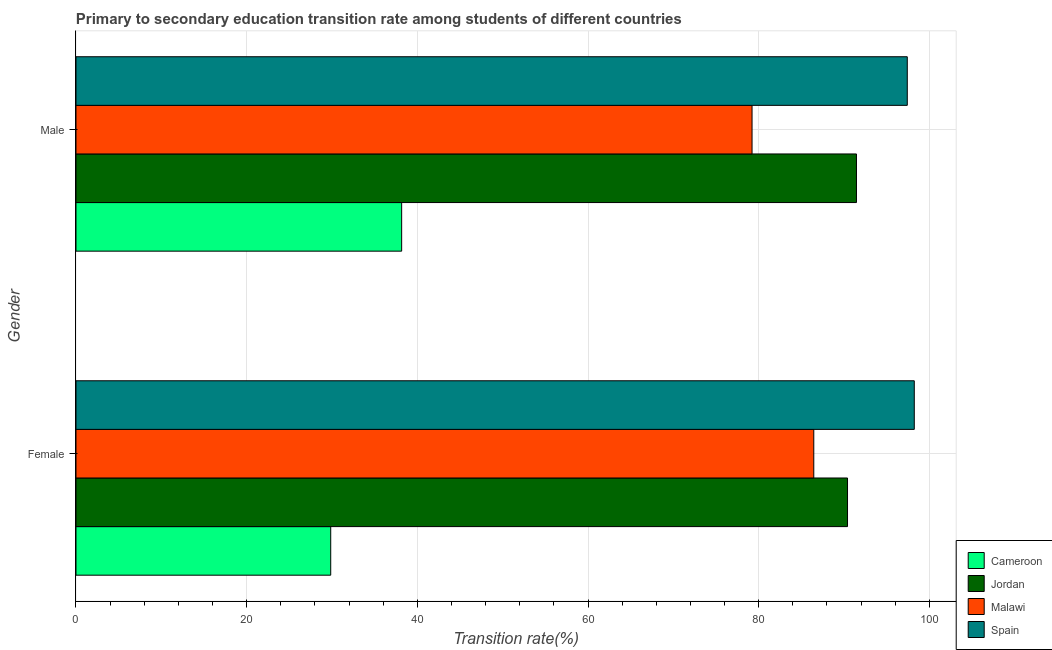How many different coloured bars are there?
Offer a very short reply. 4. How many groups of bars are there?
Offer a terse response. 2. Are the number of bars per tick equal to the number of legend labels?
Your answer should be very brief. Yes. How many bars are there on the 2nd tick from the top?
Ensure brevity in your answer.  4. What is the label of the 2nd group of bars from the top?
Your answer should be very brief. Female. What is the transition rate among male students in Malawi?
Ensure brevity in your answer.  79.22. Across all countries, what is the maximum transition rate among male students?
Offer a very short reply. 97.41. Across all countries, what is the minimum transition rate among male students?
Keep it short and to the point. 38.16. In which country was the transition rate among male students minimum?
Ensure brevity in your answer.  Cameroon. What is the total transition rate among male students in the graph?
Your answer should be compact. 306.26. What is the difference between the transition rate among male students in Malawi and that in Cameroon?
Provide a short and direct response. 41.06. What is the difference between the transition rate among female students in Cameroon and the transition rate among male students in Malawi?
Make the answer very short. -49.37. What is the average transition rate among male students per country?
Your answer should be compact. 76.57. What is the difference between the transition rate among female students and transition rate among male students in Spain?
Provide a succinct answer. 0.82. In how many countries, is the transition rate among female students greater than 24 %?
Give a very brief answer. 4. What is the ratio of the transition rate among male students in Malawi to that in Jordan?
Make the answer very short. 0.87. Is the transition rate among female students in Spain less than that in Cameroon?
Provide a short and direct response. No. What does the 4th bar from the top in Male represents?
Provide a succinct answer. Cameroon. What does the 4th bar from the bottom in Male represents?
Provide a short and direct response. Spain. How many bars are there?
Offer a very short reply. 8. Are all the bars in the graph horizontal?
Your answer should be compact. Yes. What is the difference between two consecutive major ticks on the X-axis?
Give a very brief answer. 20. Does the graph contain any zero values?
Keep it short and to the point. No. Does the graph contain grids?
Provide a succinct answer. Yes. Where does the legend appear in the graph?
Provide a short and direct response. Bottom right. How many legend labels are there?
Make the answer very short. 4. How are the legend labels stacked?
Make the answer very short. Vertical. What is the title of the graph?
Ensure brevity in your answer.  Primary to secondary education transition rate among students of different countries. Does "Europe(all income levels)" appear as one of the legend labels in the graph?
Keep it short and to the point. No. What is the label or title of the X-axis?
Offer a terse response. Transition rate(%). What is the Transition rate(%) in Cameroon in Female?
Offer a terse response. 29.85. What is the Transition rate(%) of Jordan in Female?
Give a very brief answer. 90.41. What is the Transition rate(%) in Malawi in Female?
Offer a very short reply. 86.46. What is the Transition rate(%) of Spain in Female?
Your response must be concise. 98.23. What is the Transition rate(%) in Cameroon in Male?
Provide a succinct answer. 38.16. What is the Transition rate(%) of Jordan in Male?
Keep it short and to the point. 91.46. What is the Transition rate(%) of Malawi in Male?
Ensure brevity in your answer.  79.22. What is the Transition rate(%) of Spain in Male?
Offer a terse response. 97.41. Across all Gender, what is the maximum Transition rate(%) in Cameroon?
Offer a terse response. 38.16. Across all Gender, what is the maximum Transition rate(%) of Jordan?
Make the answer very short. 91.46. Across all Gender, what is the maximum Transition rate(%) of Malawi?
Provide a short and direct response. 86.46. Across all Gender, what is the maximum Transition rate(%) in Spain?
Your response must be concise. 98.23. Across all Gender, what is the minimum Transition rate(%) of Cameroon?
Offer a very short reply. 29.85. Across all Gender, what is the minimum Transition rate(%) in Jordan?
Ensure brevity in your answer.  90.41. Across all Gender, what is the minimum Transition rate(%) in Malawi?
Provide a succinct answer. 79.22. Across all Gender, what is the minimum Transition rate(%) in Spain?
Offer a very short reply. 97.41. What is the total Transition rate(%) of Cameroon in the graph?
Offer a terse response. 68.01. What is the total Transition rate(%) in Jordan in the graph?
Your answer should be very brief. 181.87. What is the total Transition rate(%) of Malawi in the graph?
Ensure brevity in your answer.  165.68. What is the total Transition rate(%) of Spain in the graph?
Make the answer very short. 195.65. What is the difference between the Transition rate(%) in Cameroon in Female and that in Male?
Offer a very short reply. -8.31. What is the difference between the Transition rate(%) of Jordan in Female and that in Male?
Keep it short and to the point. -1.05. What is the difference between the Transition rate(%) in Malawi in Female and that in Male?
Give a very brief answer. 7.23. What is the difference between the Transition rate(%) in Spain in Female and that in Male?
Provide a succinct answer. 0.82. What is the difference between the Transition rate(%) of Cameroon in Female and the Transition rate(%) of Jordan in Male?
Your response must be concise. -61.61. What is the difference between the Transition rate(%) of Cameroon in Female and the Transition rate(%) of Malawi in Male?
Ensure brevity in your answer.  -49.37. What is the difference between the Transition rate(%) in Cameroon in Female and the Transition rate(%) in Spain in Male?
Ensure brevity in your answer.  -67.56. What is the difference between the Transition rate(%) in Jordan in Female and the Transition rate(%) in Malawi in Male?
Provide a succinct answer. 11.19. What is the difference between the Transition rate(%) in Jordan in Female and the Transition rate(%) in Spain in Male?
Make the answer very short. -7. What is the difference between the Transition rate(%) of Malawi in Female and the Transition rate(%) of Spain in Male?
Give a very brief answer. -10.96. What is the average Transition rate(%) of Cameroon per Gender?
Your answer should be compact. 34.01. What is the average Transition rate(%) of Jordan per Gender?
Keep it short and to the point. 90.94. What is the average Transition rate(%) of Malawi per Gender?
Provide a succinct answer. 82.84. What is the average Transition rate(%) of Spain per Gender?
Make the answer very short. 97.82. What is the difference between the Transition rate(%) of Cameroon and Transition rate(%) of Jordan in Female?
Make the answer very short. -60.56. What is the difference between the Transition rate(%) of Cameroon and Transition rate(%) of Malawi in Female?
Your answer should be very brief. -56.61. What is the difference between the Transition rate(%) of Cameroon and Transition rate(%) of Spain in Female?
Your answer should be compact. -68.38. What is the difference between the Transition rate(%) in Jordan and Transition rate(%) in Malawi in Female?
Make the answer very short. 3.95. What is the difference between the Transition rate(%) of Jordan and Transition rate(%) of Spain in Female?
Offer a terse response. -7.82. What is the difference between the Transition rate(%) of Malawi and Transition rate(%) of Spain in Female?
Keep it short and to the point. -11.78. What is the difference between the Transition rate(%) of Cameroon and Transition rate(%) of Jordan in Male?
Provide a short and direct response. -53.3. What is the difference between the Transition rate(%) of Cameroon and Transition rate(%) of Malawi in Male?
Ensure brevity in your answer.  -41.06. What is the difference between the Transition rate(%) in Cameroon and Transition rate(%) in Spain in Male?
Offer a very short reply. -59.25. What is the difference between the Transition rate(%) in Jordan and Transition rate(%) in Malawi in Male?
Offer a very short reply. 12.24. What is the difference between the Transition rate(%) in Jordan and Transition rate(%) in Spain in Male?
Give a very brief answer. -5.95. What is the difference between the Transition rate(%) of Malawi and Transition rate(%) of Spain in Male?
Give a very brief answer. -18.19. What is the ratio of the Transition rate(%) in Cameroon in Female to that in Male?
Keep it short and to the point. 0.78. What is the ratio of the Transition rate(%) in Jordan in Female to that in Male?
Make the answer very short. 0.99. What is the ratio of the Transition rate(%) of Malawi in Female to that in Male?
Give a very brief answer. 1.09. What is the ratio of the Transition rate(%) of Spain in Female to that in Male?
Your response must be concise. 1.01. What is the difference between the highest and the second highest Transition rate(%) in Cameroon?
Ensure brevity in your answer.  8.31. What is the difference between the highest and the second highest Transition rate(%) of Jordan?
Offer a very short reply. 1.05. What is the difference between the highest and the second highest Transition rate(%) of Malawi?
Make the answer very short. 7.23. What is the difference between the highest and the second highest Transition rate(%) in Spain?
Make the answer very short. 0.82. What is the difference between the highest and the lowest Transition rate(%) of Cameroon?
Make the answer very short. 8.31. What is the difference between the highest and the lowest Transition rate(%) in Jordan?
Keep it short and to the point. 1.05. What is the difference between the highest and the lowest Transition rate(%) of Malawi?
Your answer should be compact. 7.23. What is the difference between the highest and the lowest Transition rate(%) in Spain?
Keep it short and to the point. 0.82. 